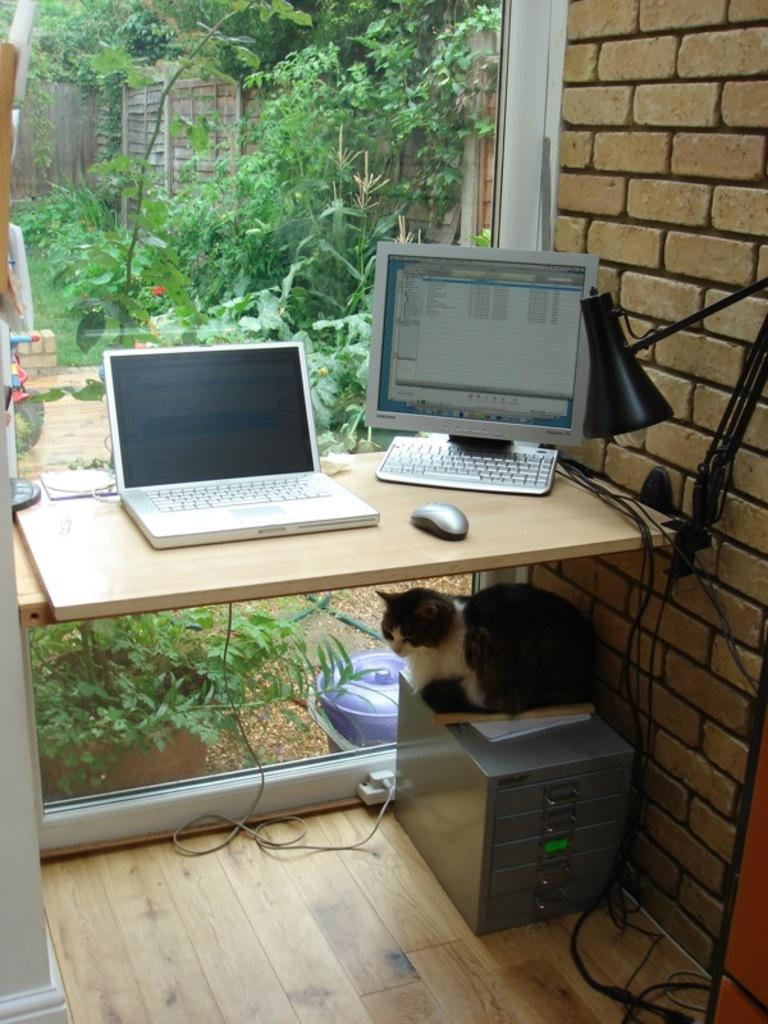What electronic device is on the table in the image? There is a laptop and a computer on the table in the image. What is the cat doing in the image? The cat is sitting under the table. Where is the cat sitting? The cat is sitting on a box. What can be seen in the background of the image? There is a tree and a wall in the background of the image. What type of chalk is the farmer using to write on the wall in the image? There is no farmer or chalk present in the image. 